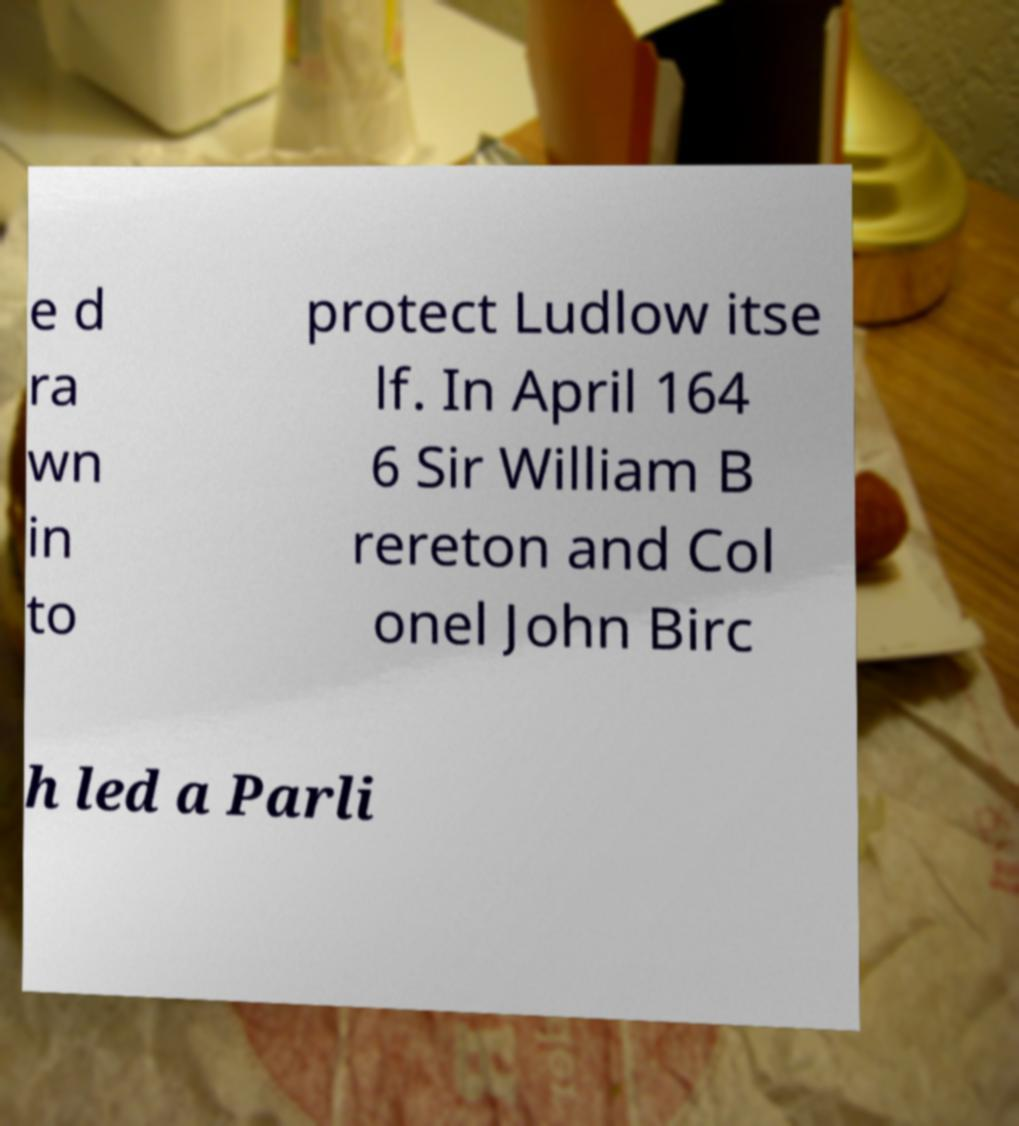There's text embedded in this image that I need extracted. Can you transcribe it verbatim? e d ra wn in to protect Ludlow itse lf. In April 164 6 Sir William B rereton and Col onel John Birc h led a Parli 